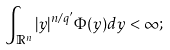<formula> <loc_0><loc_0><loc_500><loc_500>\int _ { \mathbb { R } ^ { n } } | y | ^ { n / q ^ { \prime } } \Phi ( y ) d y < \infty ;</formula> 